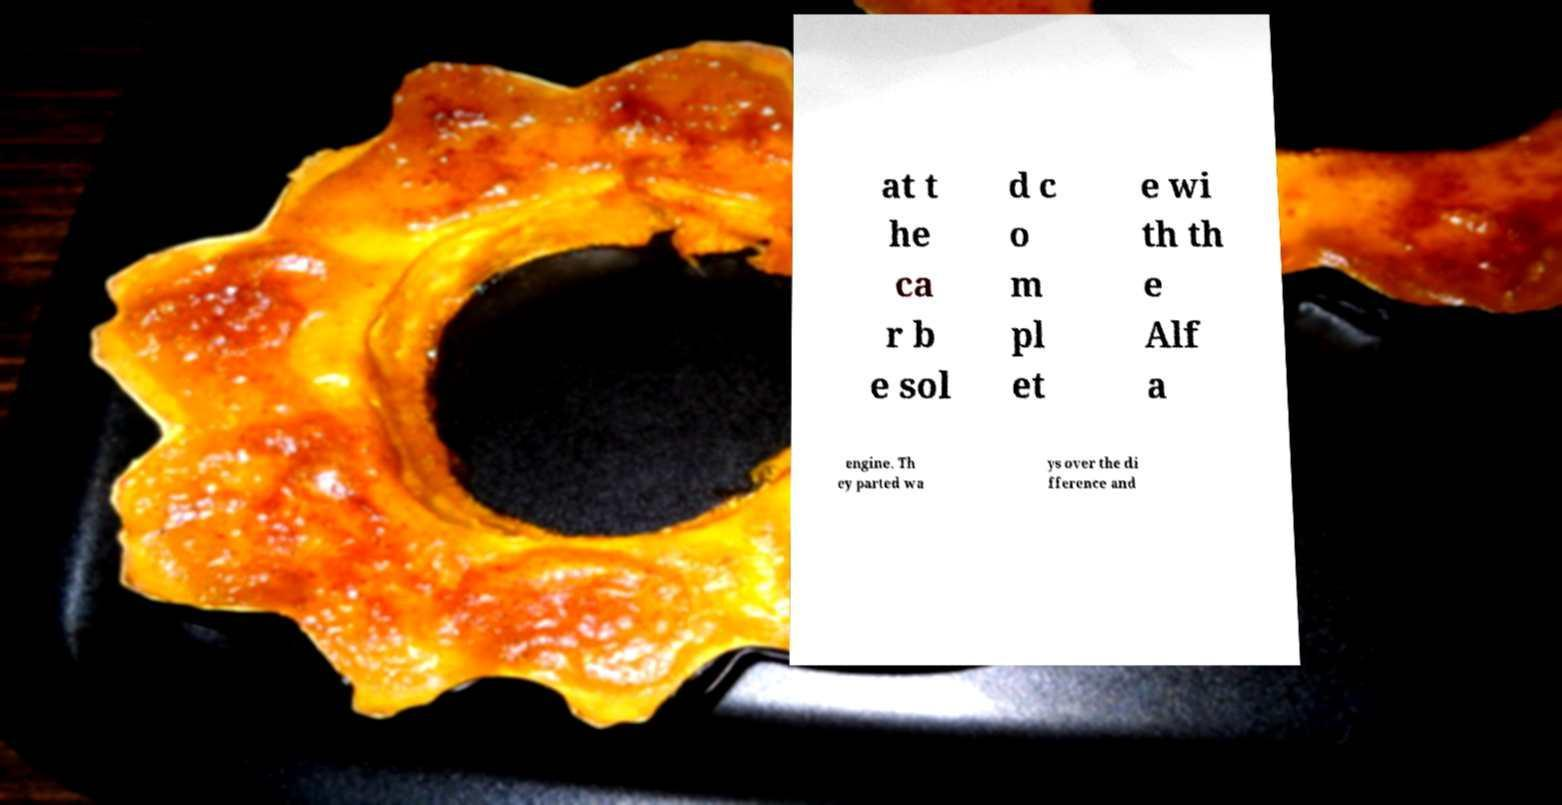Please identify and transcribe the text found in this image. at t he ca r b e sol d c o m pl et e wi th th e Alf a engine. Th ey parted wa ys over the di fference and 